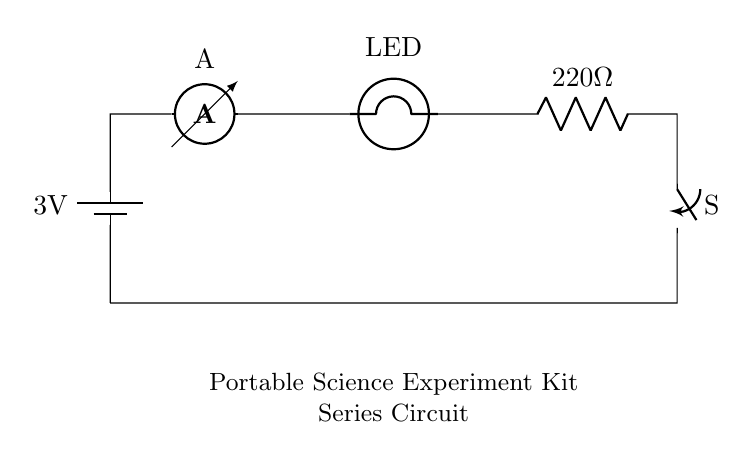What is the voltage of the battery? The voltage of the battery in the circuit is indicated as 3V. This is shown directly on the battery symbol in the circuit diagram.
Answer: 3V What type of circuit is depicted? The circuit depicted is a series circuit, as indicated by the components being connected in a single path without any branching. This means that the current flows through each component one after another in a loop.
Answer: Series circuit How many components are in the circuit? The circuit contains five components: one battery, one ammeter, one LED, one resistor, and one switch. Each component is connected in a single path, making it easy to count them directly.
Answer: Five What is the resistance value in this circuit? The resistance value in the circuit is labeled as 220 ohms on the resistor symbol. This is crucial for determining the current flow based on Ohm's Law.
Answer: 220 ohms What will happen if the switch is opened? If the switch is opened, the circuit will be broken, and the current will stop flowing through the circuit. This means that none of the components will function, including the LED.
Answer: Current stops What does the ammeter measure? The ammeter measures the current flowing through the circuit. It is placed in the series path, allowing it to get the same current value that flows through the LED and the resistor.
Answer: Current What role does the LED play in this circuit? The LED acts as an indicator that the circuit is functioning. When current flows through it, the LED will light up, showing that the circuit is complete and operational.
Answer: Indicator 